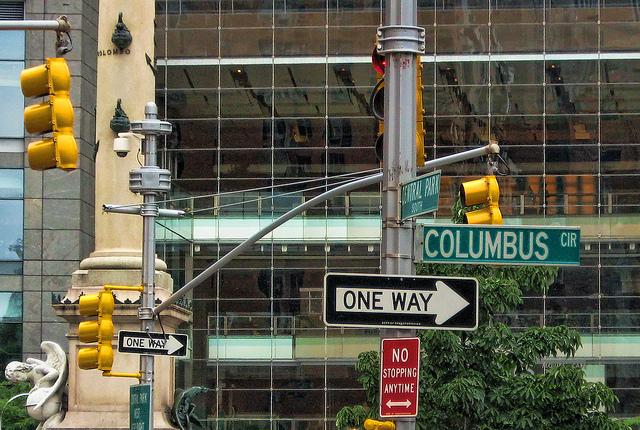Who are the street signs for?

Choices:
A) drivers
B) directions
C) downtown
D) pedestrians drivers 